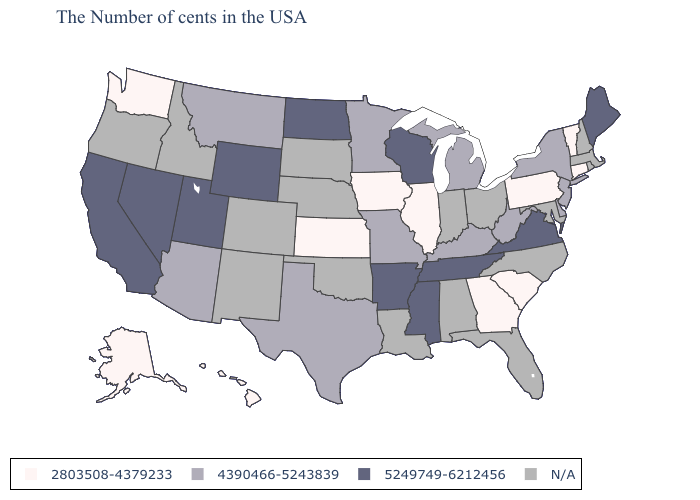Does Utah have the highest value in the West?
Give a very brief answer. Yes. Does Iowa have the lowest value in the MidWest?
Be succinct. Yes. What is the value of South Dakota?
Short answer required. N/A. How many symbols are there in the legend?
Concise answer only. 4. What is the highest value in the Northeast ?
Answer briefly. 5249749-6212456. Name the states that have a value in the range 5249749-6212456?
Answer briefly. Maine, Virginia, Tennessee, Wisconsin, Mississippi, Arkansas, North Dakota, Wyoming, Utah, Nevada, California. Does the map have missing data?
Answer briefly. Yes. Name the states that have a value in the range 5249749-6212456?
Concise answer only. Maine, Virginia, Tennessee, Wisconsin, Mississippi, Arkansas, North Dakota, Wyoming, Utah, Nevada, California. What is the highest value in the West ?
Concise answer only. 5249749-6212456. Among the states that border Wyoming , which have the highest value?
Be succinct. Utah. Is the legend a continuous bar?
Keep it brief. No. What is the lowest value in states that border Tennessee?
Keep it brief. 2803508-4379233. 